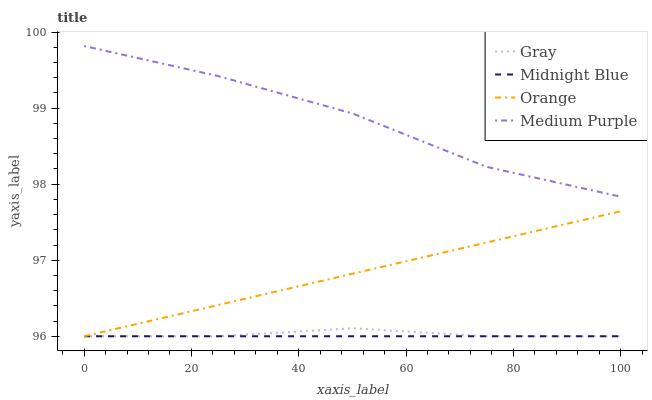Does Midnight Blue have the minimum area under the curve?
Answer yes or no. Yes. Does Medium Purple have the maximum area under the curve?
Answer yes or no. Yes. Does Gray have the minimum area under the curve?
Answer yes or no. No. Does Gray have the maximum area under the curve?
Answer yes or no. No. Is Midnight Blue the smoothest?
Answer yes or no. Yes. Is Medium Purple the roughest?
Answer yes or no. Yes. Is Gray the smoothest?
Answer yes or no. No. Is Gray the roughest?
Answer yes or no. No. Does Orange have the lowest value?
Answer yes or no. Yes. Does Medium Purple have the lowest value?
Answer yes or no. No. Does Medium Purple have the highest value?
Answer yes or no. Yes. Does Gray have the highest value?
Answer yes or no. No. Is Orange less than Medium Purple?
Answer yes or no. Yes. Is Medium Purple greater than Gray?
Answer yes or no. Yes. Does Gray intersect Midnight Blue?
Answer yes or no. Yes. Is Gray less than Midnight Blue?
Answer yes or no. No. Is Gray greater than Midnight Blue?
Answer yes or no. No. Does Orange intersect Medium Purple?
Answer yes or no. No. 